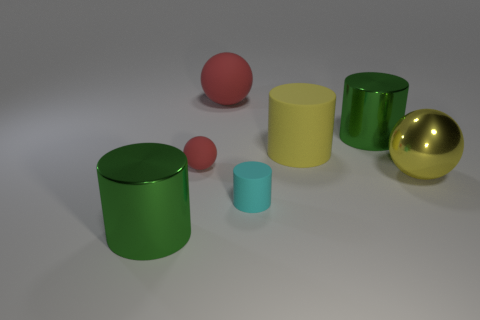Is the number of rubber things to the left of the big matte cylinder less than the number of tiny rubber things?
Your answer should be very brief. No. There is a yellow sphere that is in front of the green shiny cylinder that is behind the shiny cylinder that is in front of the large yellow metal sphere; what is its material?
Keep it short and to the point. Metal. How many objects are green metal cylinders behind the large yellow shiny ball or balls to the left of the cyan matte thing?
Ensure brevity in your answer.  3. There is a tiny thing that is the same shape as the large yellow rubber thing; what material is it?
Offer a very short reply. Rubber. How many rubber objects are yellow cylinders or red objects?
Your answer should be compact. 3. What is the shape of the red object that is made of the same material as the small red sphere?
Offer a terse response. Sphere. How many other matte objects have the same shape as the small red matte object?
Ensure brevity in your answer.  1. There is a large green thing behind the large yellow matte cylinder; does it have the same shape as the big metallic thing in front of the small cyan object?
Your answer should be compact. Yes. How many objects are either yellow matte cylinders or balls that are on the left side of the cyan object?
Make the answer very short. 3. There is a large rubber thing that is the same color as the large metal ball; what shape is it?
Give a very brief answer. Cylinder. 